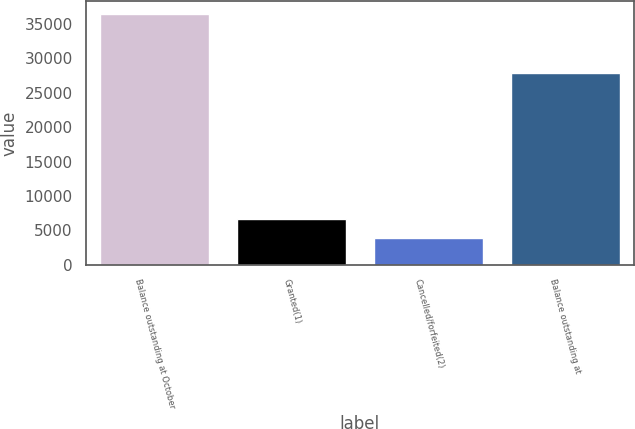<chart> <loc_0><loc_0><loc_500><loc_500><bar_chart><fcel>Balance outstanding at October<fcel>Granted(1)<fcel>Cancelled/forfeited(2)<fcel>Balance outstanding at<nl><fcel>36447<fcel>6702.5<fcel>3918<fcel>27868<nl></chart> 